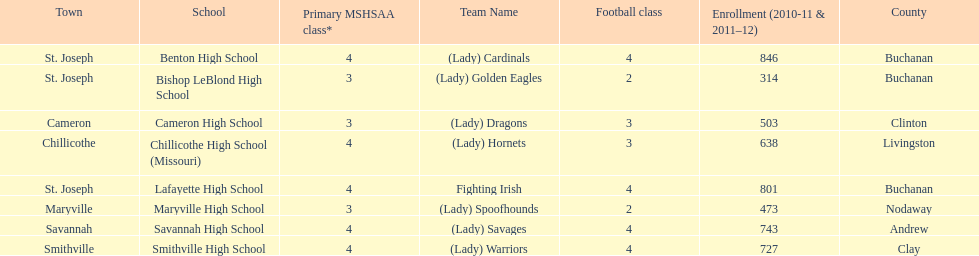Which school has the least amount of student enrollment between 2010-2011 and 2011-2012? Bishop LeBlond High School. 